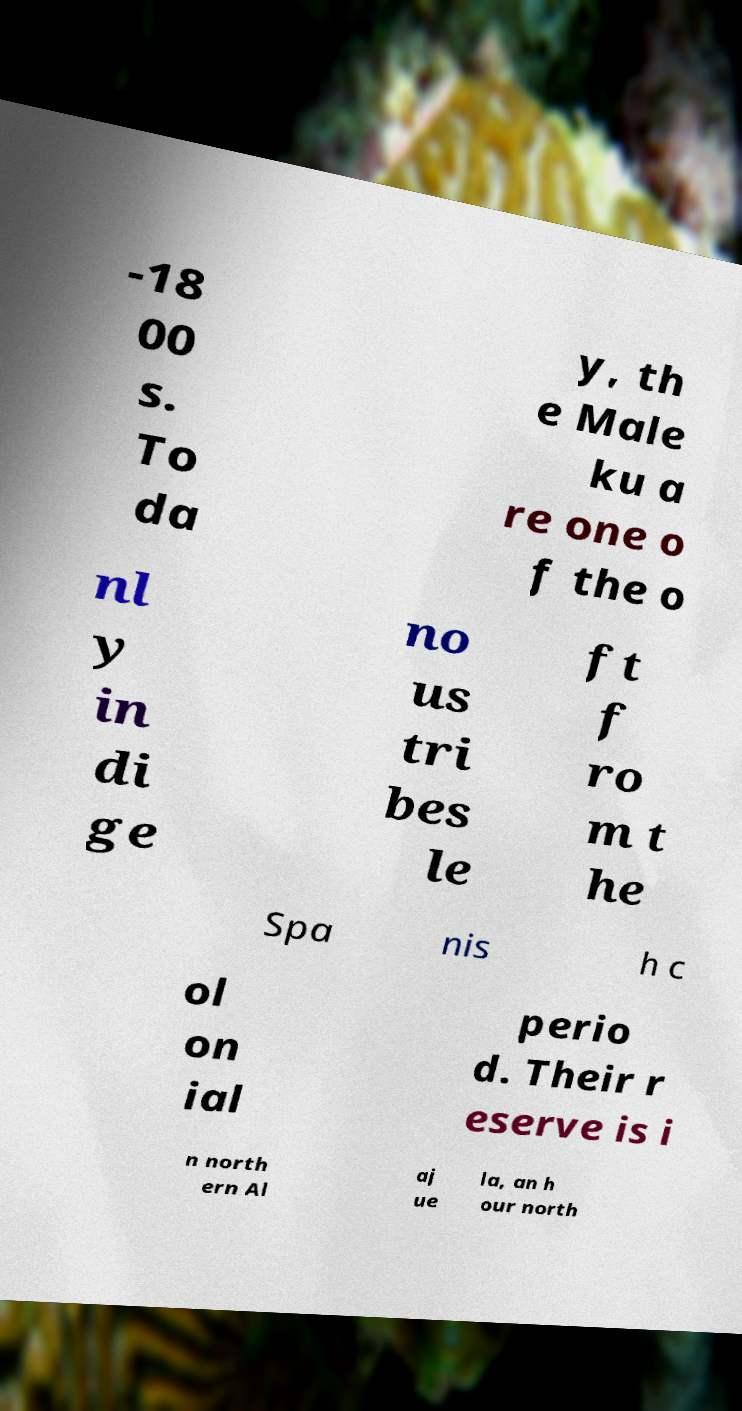I need the written content from this picture converted into text. Can you do that? -18 00 s. To da y, th e Male ku a re one o f the o nl y in di ge no us tri bes le ft f ro m t he Spa nis h c ol on ial perio d. Their r eserve is i n north ern Al aj ue la, an h our north 